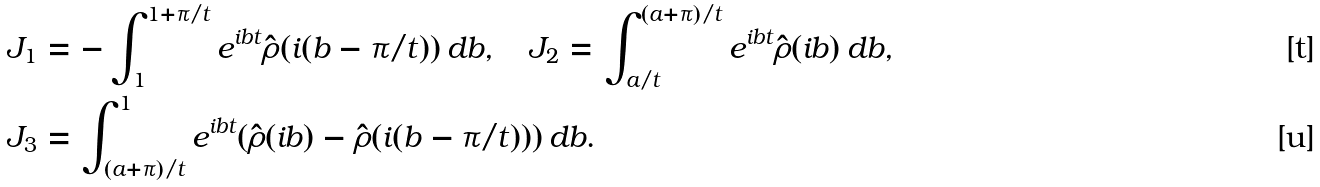Convert formula to latex. <formula><loc_0><loc_0><loc_500><loc_500>J _ { 1 } & = - \int _ { 1 } ^ { 1 + \pi / t } e ^ { i b t } \hat { \rho } ( i ( b - \pi / t ) ) \, d b , \quad J _ { 2 } = \int _ { a / t } ^ { ( a + \pi ) / t } e ^ { i b t } \hat { \rho } ( i b ) \, d b , \\ J _ { 3 } & = \int _ { ( a + \pi ) / t } ^ { 1 } e ^ { i b t } ( \hat { \rho } ( i b ) - \hat { \rho } ( i ( b - \pi / t ) ) ) \, d b .</formula> 